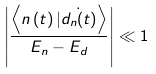<formula> <loc_0><loc_0><loc_500><loc_500>\left | \frac { \left \langle n \left ( t \right ) | \dot { d _ { n } ( t ) } \right \rangle } { E _ { n } - E _ { d } } \right | \ll 1</formula> 